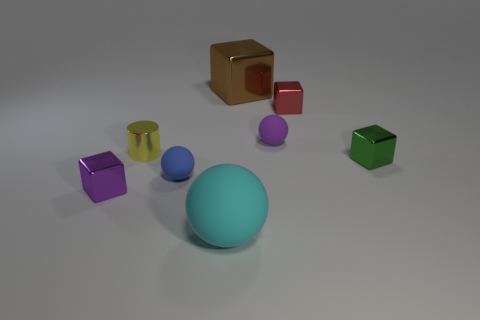What number of tiny metallic blocks are to the left of the purple rubber sphere?
Keep it short and to the point. 1. Is the number of cyan matte things in front of the cyan ball the same as the number of yellow things that are behind the small red object?
Your answer should be very brief. Yes. There is a matte thing behind the blue rubber object; is it the same shape as the tiny green thing?
Provide a succinct answer. No. There is a purple matte sphere; does it have the same size as the object that is on the left side of the tiny metal cylinder?
Offer a terse response. Yes. What number of other things are there of the same color as the large rubber sphere?
Offer a very short reply. 0. There is a red shiny cube; are there any metal cylinders behind it?
Offer a terse response. No. What number of things are either tiny objects or tiny metal things behind the small yellow metal cylinder?
Offer a very short reply. 6. There is a shiny thing on the left side of the metal cylinder; is there a ball that is in front of it?
Your response must be concise. Yes. There is a large thing that is on the left side of the large object behind the shiny cube on the left side of the yellow shiny cylinder; what shape is it?
Give a very brief answer. Sphere. What color is the small shiny cube that is in front of the yellow shiny thing and to the right of the tiny yellow metallic cylinder?
Ensure brevity in your answer.  Green. 